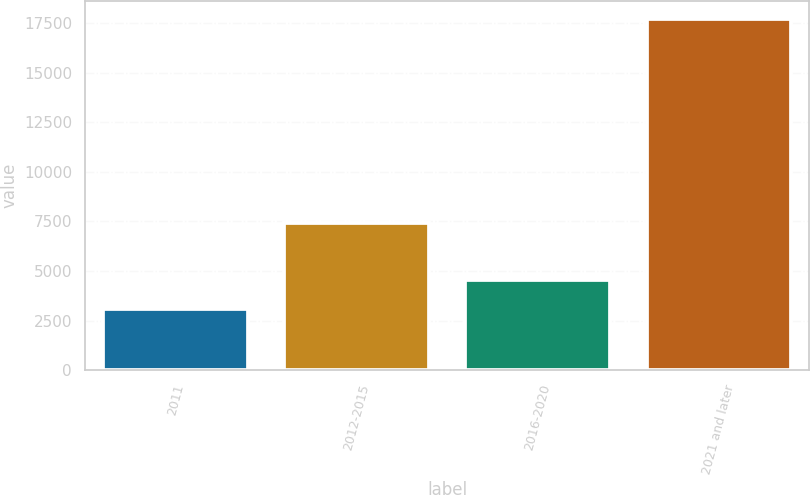Convert chart to OTSL. <chart><loc_0><loc_0><loc_500><loc_500><bar_chart><fcel>2011<fcel>2012-2015<fcel>2016-2020<fcel>2021 and later<nl><fcel>3072<fcel>7433<fcel>4538<fcel>17732<nl></chart> 